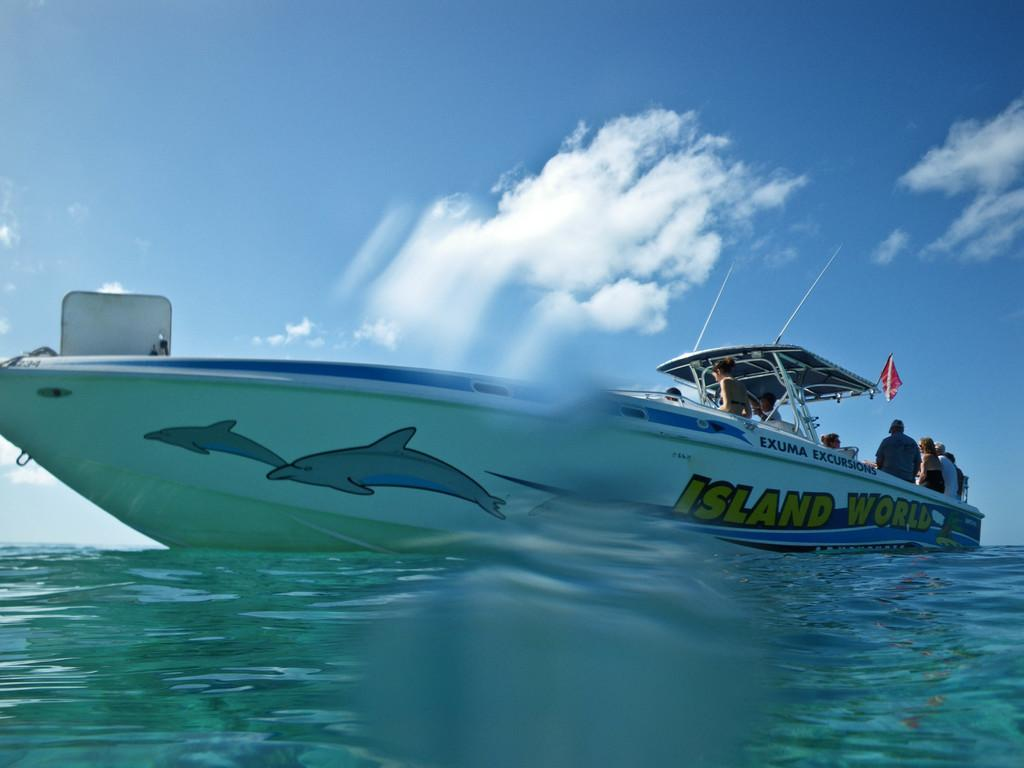What is the main subject of the image? The main subject of the image is a boat. Where is the boat located in the image? The boat is on the surface of water. Are there any people in the boat? Yes, there are people sitting in the boat. What is visible at the top of the image? The sky is visible at the top of the image. How would you describe the sky in the image? The sky appears to be cloudy. What type of zinc can be seen on the elbow of the person sitting in the boat? There is no zinc or mention of an elbow in the image; it features a boat on water with people sitting in it. 